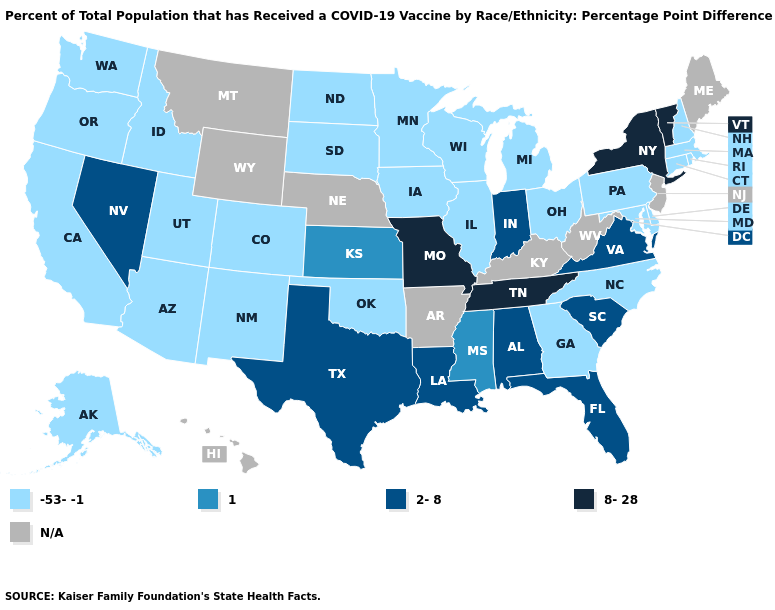Does Vermont have the highest value in the USA?
Quick response, please. Yes. Among the states that border South Carolina , which have the highest value?
Give a very brief answer. Georgia, North Carolina. Which states have the lowest value in the USA?
Concise answer only. Alaska, Arizona, California, Colorado, Connecticut, Delaware, Georgia, Idaho, Illinois, Iowa, Maryland, Massachusetts, Michigan, Minnesota, New Hampshire, New Mexico, North Carolina, North Dakota, Ohio, Oklahoma, Oregon, Pennsylvania, Rhode Island, South Dakota, Utah, Washington, Wisconsin. What is the highest value in states that border Minnesota?
Give a very brief answer. -53--1. Name the states that have a value in the range 1?
Short answer required. Kansas, Mississippi. Among the states that border Nebraska , which have the highest value?
Short answer required. Missouri. What is the value of North Dakota?
Be succinct. -53--1. Does Utah have the lowest value in the USA?
Write a very short answer. Yes. What is the lowest value in the USA?
Write a very short answer. -53--1. What is the highest value in states that border Louisiana?
Be succinct. 2-8. Does the map have missing data?
Be succinct. Yes. What is the value of Pennsylvania?
Answer briefly. -53--1. Does the map have missing data?
Write a very short answer. Yes. What is the value of Arkansas?
Give a very brief answer. N/A. Name the states that have a value in the range 8-28?
Concise answer only. Missouri, New York, Tennessee, Vermont. 